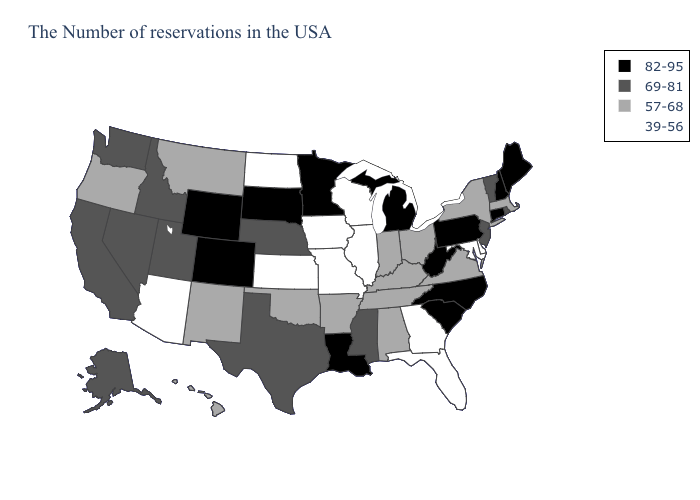What is the value of Georgia?
Give a very brief answer. 39-56. Does the map have missing data?
Write a very short answer. No. Name the states that have a value in the range 69-81?
Short answer required. Rhode Island, Vermont, New Jersey, Mississippi, Nebraska, Texas, Utah, Idaho, Nevada, California, Washington, Alaska. Name the states that have a value in the range 82-95?
Answer briefly. Maine, New Hampshire, Connecticut, Pennsylvania, North Carolina, South Carolina, West Virginia, Michigan, Louisiana, Minnesota, South Dakota, Wyoming, Colorado. Name the states that have a value in the range 57-68?
Write a very short answer. Massachusetts, New York, Virginia, Ohio, Kentucky, Indiana, Alabama, Tennessee, Arkansas, Oklahoma, New Mexico, Montana, Oregon, Hawaii. What is the value of Delaware?
Give a very brief answer. 39-56. Does the map have missing data?
Short answer required. No. Which states have the lowest value in the MidWest?
Give a very brief answer. Wisconsin, Illinois, Missouri, Iowa, Kansas, North Dakota. What is the highest value in states that border Tennessee?
Concise answer only. 82-95. Name the states that have a value in the range 69-81?
Quick response, please. Rhode Island, Vermont, New Jersey, Mississippi, Nebraska, Texas, Utah, Idaho, Nevada, California, Washington, Alaska. Which states have the highest value in the USA?
Concise answer only. Maine, New Hampshire, Connecticut, Pennsylvania, North Carolina, South Carolina, West Virginia, Michigan, Louisiana, Minnesota, South Dakota, Wyoming, Colorado. Name the states that have a value in the range 39-56?
Be succinct. Delaware, Maryland, Florida, Georgia, Wisconsin, Illinois, Missouri, Iowa, Kansas, North Dakota, Arizona. What is the lowest value in the USA?
Quick response, please. 39-56. Which states have the lowest value in the West?
Keep it brief. Arizona. 